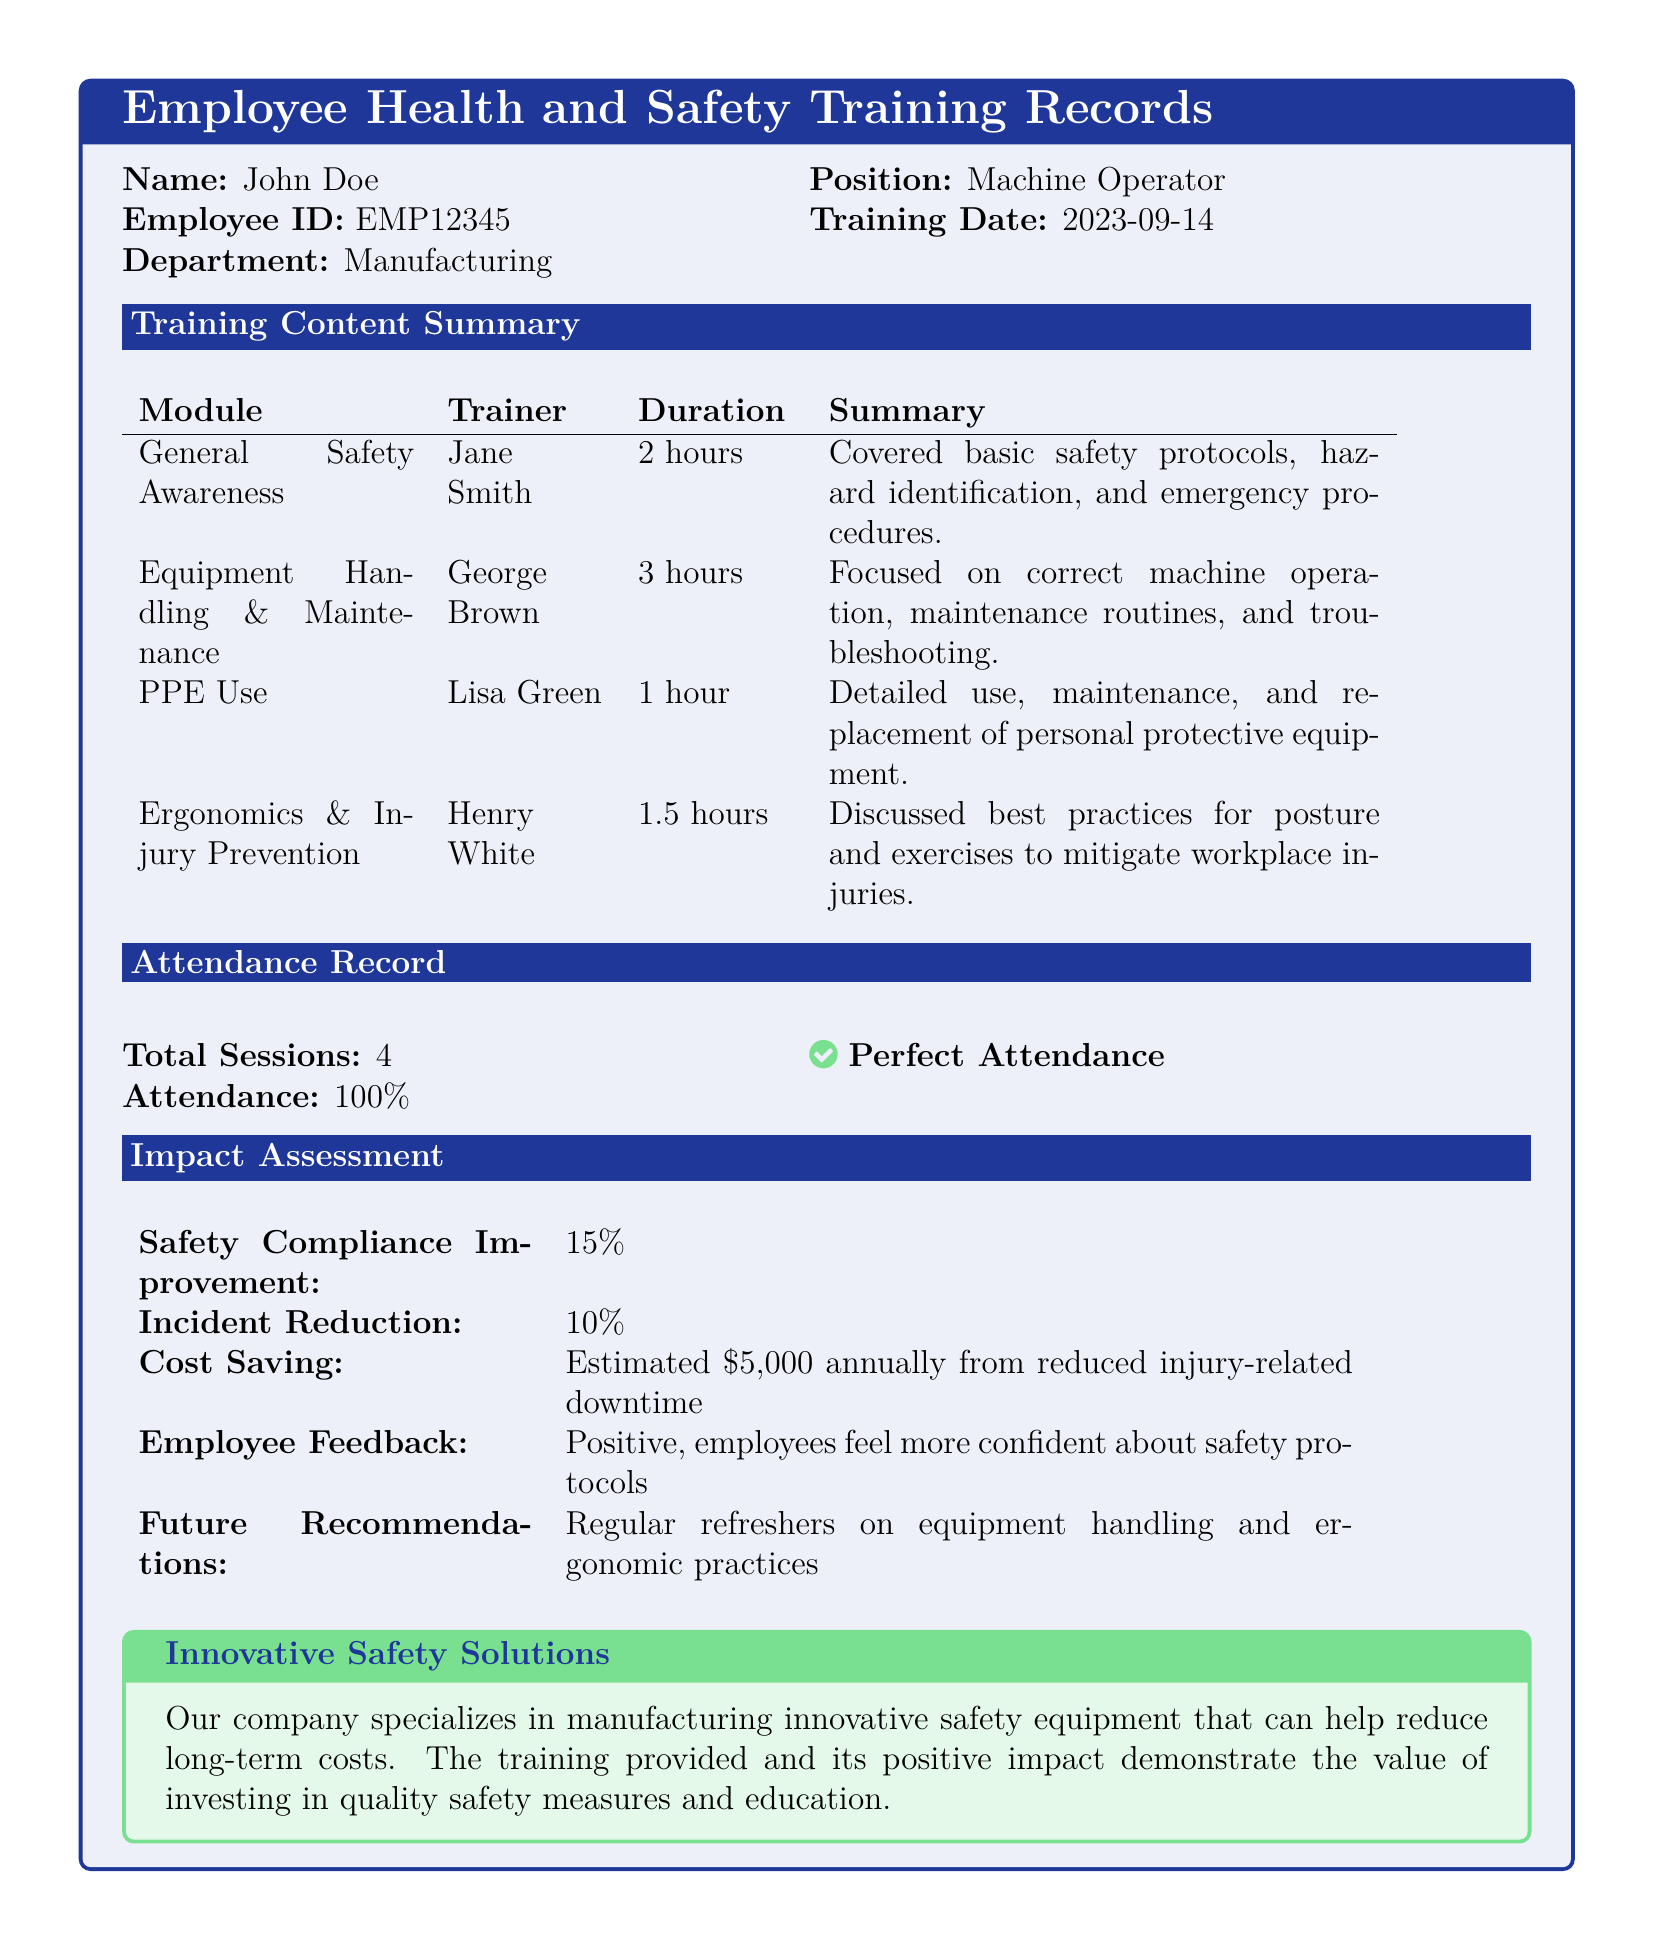What is the employee's name? The document states the employee's name as "John Doe."
Answer: John Doe What is the training date? The document specifies the training date as "2023-09-14."
Answer: 2023-09-14 How many total sessions were held? The attendance record indicates that there were "4" total sessions.
Answer: 4 What percentage improvement was reported in safety compliance? The impact assessment shows a "15%" improvement in safety compliance.
Answer: 15% What is the estimated annual cost saving mentioned? The document mentions an estimated cost saving of "$5,000" annually.
Answer: $5,000 Who conducted the Equipment Handling & Maintenance training? According to the training content summary, this module was conducted by "George Brown."
Answer: George Brown What feedback did employees provide after the training? The impact assessment states that feedback was "Positive."
Answer: Positive What is the focus of the Ergonomics & Injury Prevention module? The summary explains it discusses "best practices for posture and exercises."
Answer: best practices for posture and exercises What is the training content for PPE Use? The document states that this module detailed "use, maintenance, and replacement of personal protective equipment."
Answer: use, maintenance, and replacement of personal protective equipment What do the future recommendations suggest? The document recommends "Regular refreshers on equipment handling and ergonomic practices."
Answer: Regular refreshers on equipment handling and ergonomic practices 